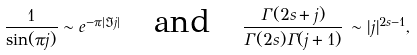Convert formula to latex. <formula><loc_0><loc_0><loc_500><loc_500>\frac { 1 } { \sin ( \pi j ) } \sim e ^ { - \pi | \Im j | } \quad \text {and} \quad \frac { \Gamma ( 2 s + j ) } { \Gamma ( 2 s ) \Gamma ( j + 1 ) } \, \sim | j | ^ { 2 s - 1 } ,</formula> 